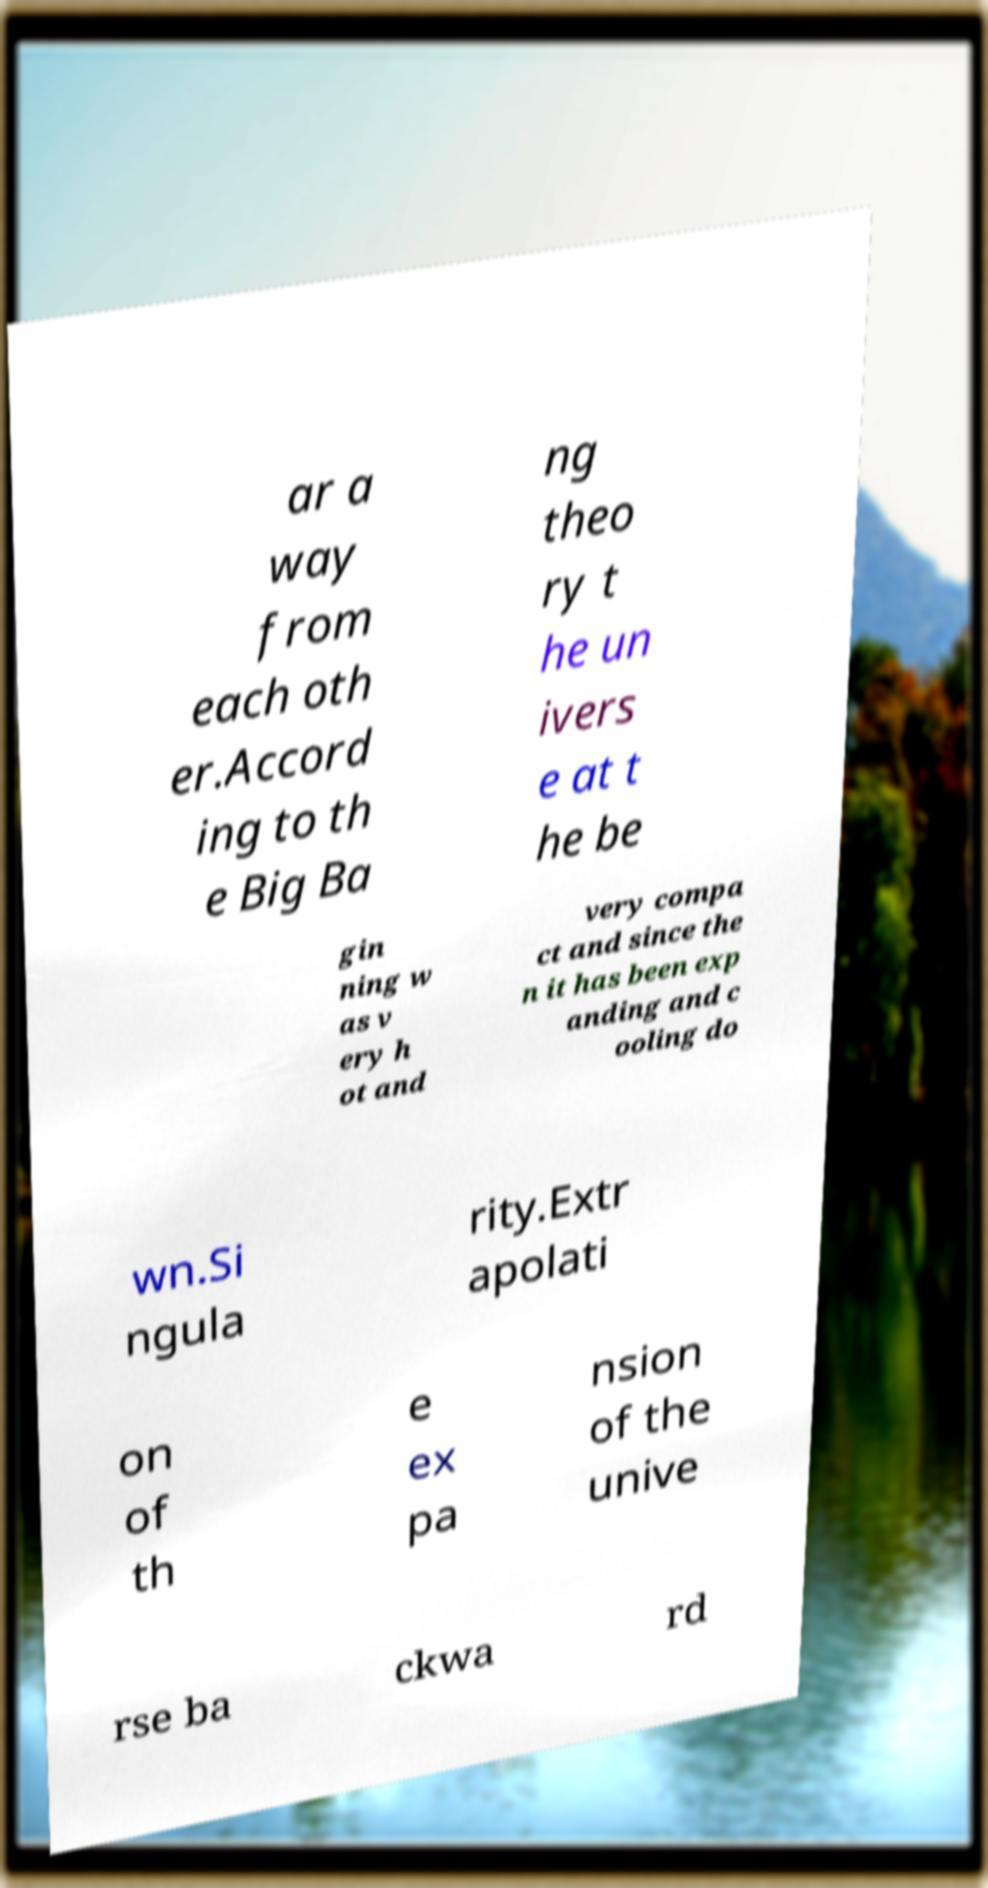Please read and relay the text visible in this image. What does it say? ar a way from each oth er.Accord ing to th e Big Ba ng theo ry t he un ivers e at t he be gin ning w as v ery h ot and very compa ct and since the n it has been exp anding and c ooling do wn.Si ngula rity.Extr apolati on of th e ex pa nsion of the unive rse ba ckwa rd 